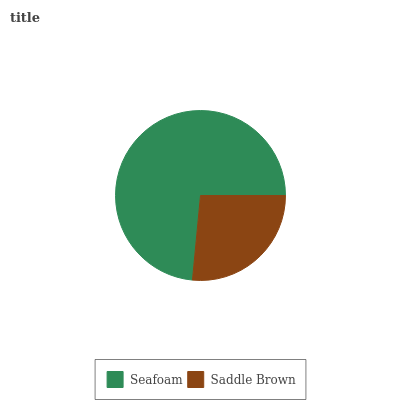Is Saddle Brown the minimum?
Answer yes or no. Yes. Is Seafoam the maximum?
Answer yes or no. Yes. Is Saddle Brown the maximum?
Answer yes or no. No. Is Seafoam greater than Saddle Brown?
Answer yes or no. Yes. Is Saddle Brown less than Seafoam?
Answer yes or no. Yes. Is Saddle Brown greater than Seafoam?
Answer yes or no. No. Is Seafoam less than Saddle Brown?
Answer yes or no. No. Is Seafoam the high median?
Answer yes or no. Yes. Is Saddle Brown the low median?
Answer yes or no. Yes. Is Saddle Brown the high median?
Answer yes or no. No. Is Seafoam the low median?
Answer yes or no. No. 